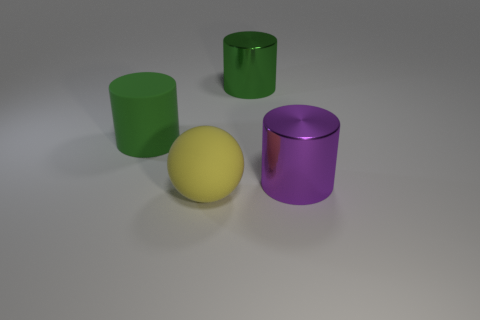There is a large object behind the green matte thing; is it the same color as the large rubber cylinder?
Offer a terse response. Yes. How many metallic things are the same color as the rubber cylinder?
Your answer should be very brief. 1. What number of tiny metal objects are there?
Ensure brevity in your answer.  0. How many green objects are made of the same material as the yellow ball?
Your answer should be compact. 1. What is the material of the big yellow ball?
Ensure brevity in your answer.  Rubber. What material is the large object that is to the right of the big green cylinder that is right of the yellow ball in front of the big purple cylinder?
Provide a short and direct response. Metal. Is there anything else that has the same shape as the yellow object?
Ensure brevity in your answer.  No. The other large matte thing that is the same shape as the large purple thing is what color?
Offer a very short reply. Green. Does the thing on the left side of the yellow matte object have the same color as the object behind the green rubber cylinder?
Provide a short and direct response. Yes. Are there more cylinders in front of the green shiny object than small red balls?
Your response must be concise. Yes. 